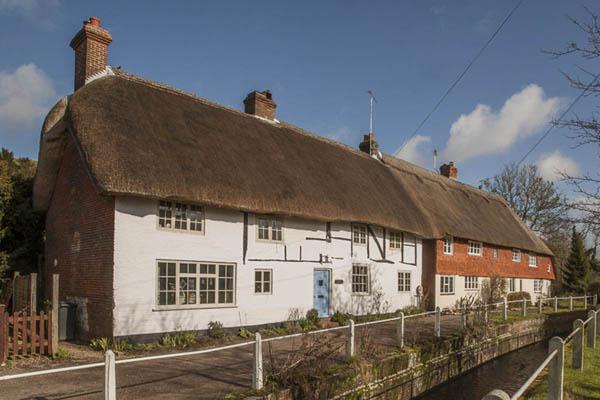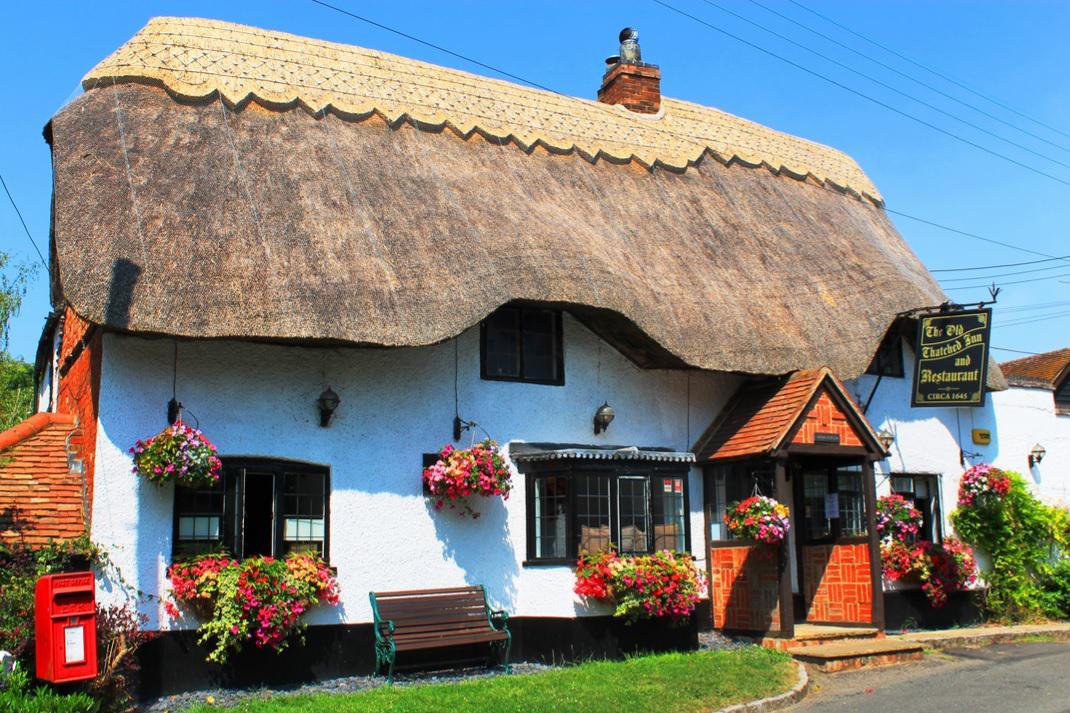The first image is the image on the left, the second image is the image on the right. Given the left and right images, does the statement "The left image shows potted plants on a grassless surface in front of an orangish building with a curving 'cap' along the peak of the roof and a notch to accommodate a window." hold true? Answer yes or no. No. The first image is the image on the left, the second image is the image on the right. Assess this claim about the two images: "In at least one image there is is a red rust house with a black roof and a single chimney on it.". Correct or not? Answer yes or no. No. 